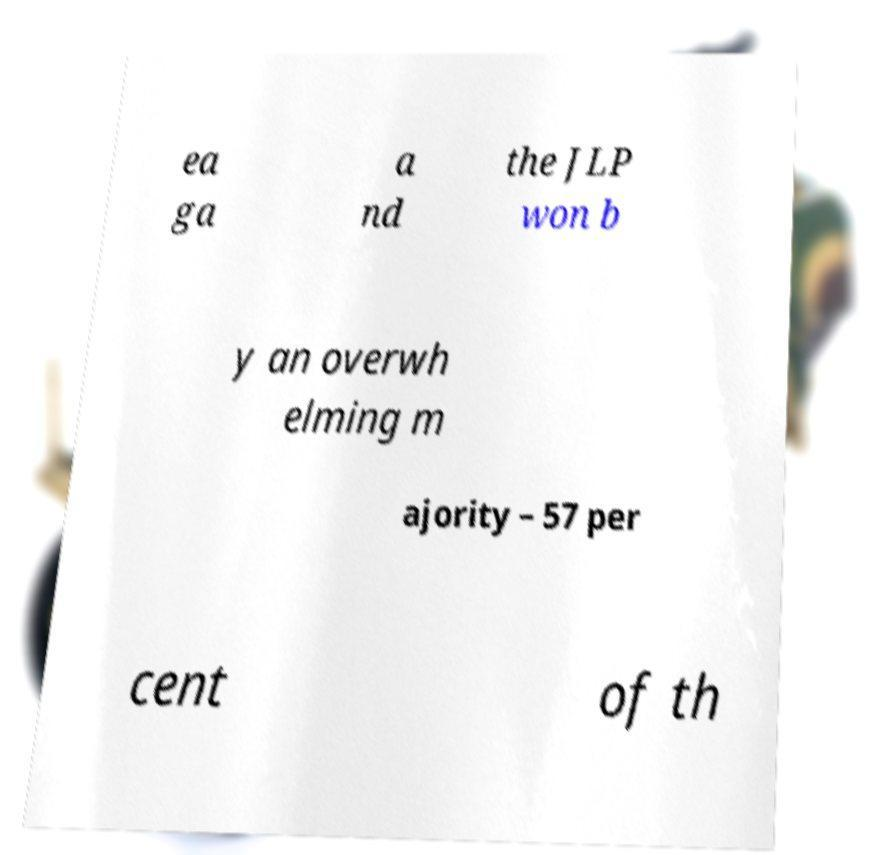For documentation purposes, I need the text within this image transcribed. Could you provide that? ea ga a nd the JLP won b y an overwh elming m ajority – 57 per cent of th 